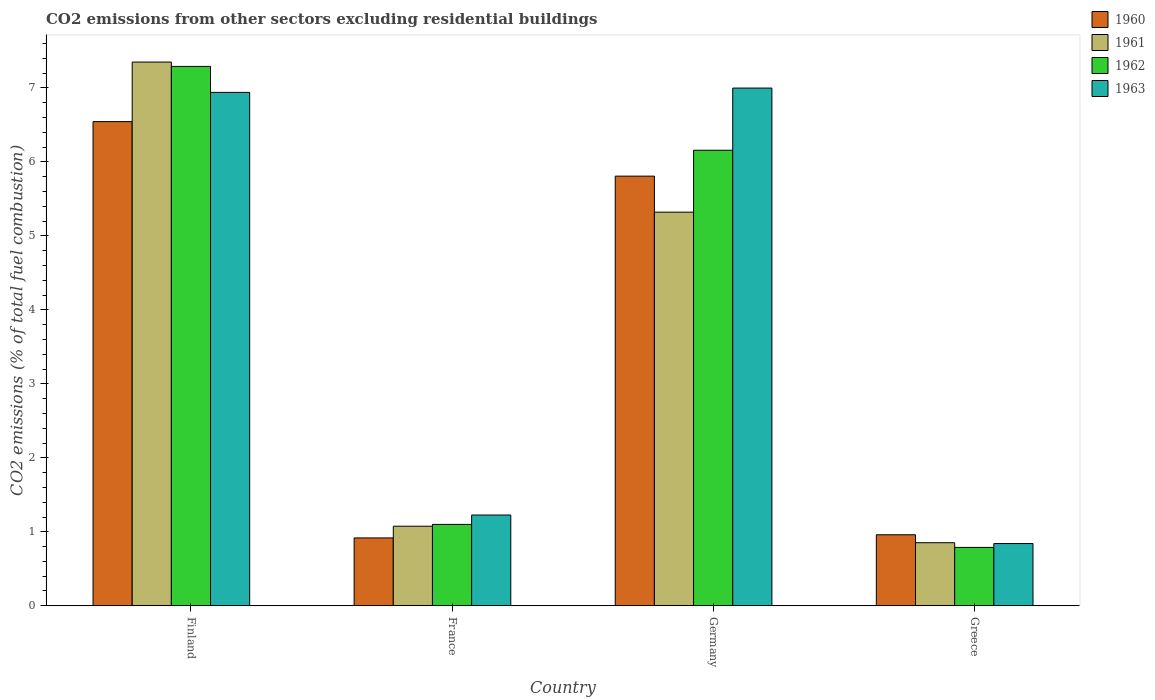How many different coloured bars are there?
Give a very brief answer. 4. Are the number of bars per tick equal to the number of legend labels?
Keep it short and to the point. Yes. How many bars are there on the 4th tick from the left?
Provide a succinct answer. 4. What is the label of the 1st group of bars from the left?
Offer a terse response. Finland. In how many cases, is the number of bars for a given country not equal to the number of legend labels?
Your answer should be very brief. 0. What is the total CO2 emitted in 1961 in Finland?
Provide a short and direct response. 7.35. Across all countries, what is the maximum total CO2 emitted in 1963?
Offer a very short reply. 7. Across all countries, what is the minimum total CO2 emitted in 1961?
Provide a short and direct response. 0.85. In which country was the total CO2 emitted in 1960 maximum?
Keep it short and to the point. Finland. What is the total total CO2 emitted in 1961 in the graph?
Ensure brevity in your answer.  14.6. What is the difference between the total CO2 emitted in 1960 in France and that in Greece?
Make the answer very short. -0.04. What is the difference between the total CO2 emitted in 1962 in Germany and the total CO2 emitted in 1961 in Finland?
Your response must be concise. -1.19. What is the average total CO2 emitted in 1961 per country?
Give a very brief answer. 3.65. What is the difference between the total CO2 emitted of/in 1960 and total CO2 emitted of/in 1962 in Greece?
Ensure brevity in your answer.  0.17. What is the ratio of the total CO2 emitted in 1963 in Germany to that in Greece?
Your answer should be compact. 8.32. What is the difference between the highest and the second highest total CO2 emitted in 1960?
Ensure brevity in your answer.  -4.85. What is the difference between the highest and the lowest total CO2 emitted in 1961?
Your response must be concise. 6.5. Is it the case that in every country, the sum of the total CO2 emitted in 1960 and total CO2 emitted in 1962 is greater than the sum of total CO2 emitted in 1963 and total CO2 emitted in 1961?
Your answer should be compact. No. What does the 1st bar from the left in Germany represents?
Provide a succinct answer. 1960. How many bars are there?
Offer a terse response. 16. Are the values on the major ticks of Y-axis written in scientific E-notation?
Ensure brevity in your answer.  No. Does the graph contain any zero values?
Ensure brevity in your answer.  No. Does the graph contain grids?
Ensure brevity in your answer.  No. How many legend labels are there?
Provide a short and direct response. 4. How are the legend labels stacked?
Your answer should be compact. Vertical. What is the title of the graph?
Offer a very short reply. CO2 emissions from other sectors excluding residential buildings. Does "2012" appear as one of the legend labels in the graph?
Provide a short and direct response. No. What is the label or title of the X-axis?
Your response must be concise. Country. What is the label or title of the Y-axis?
Give a very brief answer. CO2 emissions (% of total fuel combustion). What is the CO2 emissions (% of total fuel combustion) of 1960 in Finland?
Give a very brief answer. 6.54. What is the CO2 emissions (% of total fuel combustion) in 1961 in Finland?
Your answer should be very brief. 7.35. What is the CO2 emissions (% of total fuel combustion) of 1962 in Finland?
Provide a short and direct response. 7.29. What is the CO2 emissions (% of total fuel combustion) in 1963 in Finland?
Offer a terse response. 6.94. What is the CO2 emissions (% of total fuel combustion) of 1960 in France?
Offer a terse response. 0.92. What is the CO2 emissions (% of total fuel combustion) of 1961 in France?
Offer a very short reply. 1.08. What is the CO2 emissions (% of total fuel combustion) in 1962 in France?
Keep it short and to the point. 1.1. What is the CO2 emissions (% of total fuel combustion) in 1963 in France?
Your answer should be very brief. 1.23. What is the CO2 emissions (% of total fuel combustion) in 1960 in Germany?
Offer a very short reply. 5.81. What is the CO2 emissions (% of total fuel combustion) in 1961 in Germany?
Your response must be concise. 5.32. What is the CO2 emissions (% of total fuel combustion) in 1962 in Germany?
Keep it short and to the point. 6.16. What is the CO2 emissions (% of total fuel combustion) in 1963 in Germany?
Your response must be concise. 7. What is the CO2 emissions (% of total fuel combustion) of 1960 in Greece?
Offer a terse response. 0.96. What is the CO2 emissions (% of total fuel combustion) in 1961 in Greece?
Offer a terse response. 0.85. What is the CO2 emissions (% of total fuel combustion) of 1962 in Greece?
Your answer should be compact. 0.79. What is the CO2 emissions (% of total fuel combustion) of 1963 in Greece?
Your response must be concise. 0.84. Across all countries, what is the maximum CO2 emissions (% of total fuel combustion) of 1960?
Ensure brevity in your answer.  6.54. Across all countries, what is the maximum CO2 emissions (% of total fuel combustion) of 1961?
Ensure brevity in your answer.  7.35. Across all countries, what is the maximum CO2 emissions (% of total fuel combustion) in 1962?
Keep it short and to the point. 7.29. Across all countries, what is the maximum CO2 emissions (% of total fuel combustion) in 1963?
Provide a succinct answer. 7. Across all countries, what is the minimum CO2 emissions (% of total fuel combustion) of 1960?
Ensure brevity in your answer.  0.92. Across all countries, what is the minimum CO2 emissions (% of total fuel combustion) of 1961?
Provide a succinct answer. 0.85. Across all countries, what is the minimum CO2 emissions (% of total fuel combustion) of 1962?
Provide a short and direct response. 0.79. Across all countries, what is the minimum CO2 emissions (% of total fuel combustion) of 1963?
Offer a terse response. 0.84. What is the total CO2 emissions (% of total fuel combustion) in 1960 in the graph?
Your response must be concise. 14.23. What is the total CO2 emissions (% of total fuel combustion) of 1961 in the graph?
Provide a succinct answer. 14.6. What is the total CO2 emissions (% of total fuel combustion) of 1962 in the graph?
Give a very brief answer. 15.34. What is the total CO2 emissions (% of total fuel combustion) of 1963 in the graph?
Offer a terse response. 16.01. What is the difference between the CO2 emissions (% of total fuel combustion) of 1960 in Finland and that in France?
Your answer should be very brief. 5.63. What is the difference between the CO2 emissions (% of total fuel combustion) in 1961 in Finland and that in France?
Make the answer very short. 6.27. What is the difference between the CO2 emissions (% of total fuel combustion) of 1962 in Finland and that in France?
Offer a very short reply. 6.19. What is the difference between the CO2 emissions (% of total fuel combustion) in 1963 in Finland and that in France?
Make the answer very short. 5.71. What is the difference between the CO2 emissions (% of total fuel combustion) in 1960 in Finland and that in Germany?
Your response must be concise. 0.74. What is the difference between the CO2 emissions (% of total fuel combustion) of 1961 in Finland and that in Germany?
Your answer should be very brief. 2.03. What is the difference between the CO2 emissions (% of total fuel combustion) of 1962 in Finland and that in Germany?
Provide a short and direct response. 1.13. What is the difference between the CO2 emissions (% of total fuel combustion) in 1963 in Finland and that in Germany?
Offer a very short reply. -0.06. What is the difference between the CO2 emissions (% of total fuel combustion) in 1960 in Finland and that in Greece?
Ensure brevity in your answer.  5.58. What is the difference between the CO2 emissions (% of total fuel combustion) of 1961 in Finland and that in Greece?
Provide a short and direct response. 6.5. What is the difference between the CO2 emissions (% of total fuel combustion) of 1962 in Finland and that in Greece?
Your answer should be very brief. 6.5. What is the difference between the CO2 emissions (% of total fuel combustion) of 1963 in Finland and that in Greece?
Give a very brief answer. 6.1. What is the difference between the CO2 emissions (% of total fuel combustion) in 1960 in France and that in Germany?
Provide a succinct answer. -4.89. What is the difference between the CO2 emissions (% of total fuel combustion) in 1961 in France and that in Germany?
Offer a terse response. -4.25. What is the difference between the CO2 emissions (% of total fuel combustion) in 1962 in France and that in Germany?
Offer a terse response. -5.06. What is the difference between the CO2 emissions (% of total fuel combustion) in 1963 in France and that in Germany?
Give a very brief answer. -5.77. What is the difference between the CO2 emissions (% of total fuel combustion) in 1960 in France and that in Greece?
Give a very brief answer. -0.04. What is the difference between the CO2 emissions (% of total fuel combustion) of 1961 in France and that in Greece?
Make the answer very short. 0.22. What is the difference between the CO2 emissions (% of total fuel combustion) in 1962 in France and that in Greece?
Offer a terse response. 0.31. What is the difference between the CO2 emissions (% of total fuel combustion) of 1963 in France and that in Greece?
Ensure brevity in your answer.  0.39. What is the difference between the CO2 emissions (% of total fuel combustion) in 1960 in Germany and that in Greece?
Give a very brief answer. 4.85. What is the difference between the CO2 emissions (% of total fuel combustion) of 1961 in Germany and that in Greece?
Your answer should be very brief. 4.47. What is the difference between the CO2 emissions (% of total fuel combustion) of 1962 in Germany and that in Greece?
Ensure brevity in your answer.  5.37. What is the difference between the CO2 emissions (% of total fuel combustion) of 1963 in Germany and that in Greece?
Your answer should be compact. 6.16. What is the difference between the CO2 emissions (% of total fuel combustion) in 1960 in Finland and the CO2 emissions (% of total fuel combustion) in 1961 in France?
Ensure brevity in your answer.  5.47. What is the difference between the CO2 emissions (% of total fuel combustion) of 1960 in Finland and the CO2 emissions (% of total fuel combustion) of 1962 in France?
Your answer should be very brief. 5.44. What is the difference between the CO2 emissions (% of total fuel combustion) in 1960 in Finland and the CO2 emissions (% of total fuel combustion) in 1963 in France?
Your response must be concise. 5.32. What is the difference between the CO2 emissions (% of total fuel combustion) in 1961 in Finland and the CO2 emissions (% of total fuel combustion) in 1962 in France?
Keep it short and to the point. 6.25. What is the difference between the CO2 emissions (% of total fuel combustion) of 1961 in Finland and the CO2 emissions (% of total fuel combustion) of 1963 in France?
Your answer should be very brief. 6.12. What is the difference between the CO2 emissions (% of total fuel combustion) of 1962 in Finland and the CO2 emissions (% of total fuel combustion) of 1963 in France?
Your response must be concise. 6.06. What is the difference between the CO2 emissions (% of total fuel combustion) of 1960 in Finland and the CO2 emissions (% of total fuel combustion) of 1961 in Germany?
Your answer should be compact. 1.22. What is the difference between the CO2 emissions (% of total fuel combustion) in 1960 in Finland and the CO2 emissions (% of total fuel combustion) in 1962 in Germany?
Provide a short and direct response. 0.39. What is the difference between the CO2 emissions (% of total fuel combustion) in 1960 in Finland and the CO2 emissions (% of total fuel combustion) in 1963 in Germany?
Give a very brief answer. -0.45. What is the difference between the CO2 emissions (% of total fuel combustion) of 1961 in Finland and the CO2 emissions (% of total fuel combustion) of 1962 in Germany?
Your answer should be very brief. 1.19. What is the difference between the CO2 emissions (% of total fuel combustion) of 1961 in Finland and the CO2 emissions (% of total fuel combustion) of 1963 in Germany?
Your answer should be compact. 0.35. What is the difference between the CO2 emissions (% of total fuel combustion) in 1962 in Finland and the CO2 emissions (% of total fuel combustion) in 1963 in Germany?
Offer a very short reply. 0.29. What is the difference between the CO2 emissions (% of total fuel combustion) of 1960 in Finland and the CO2 emissions (% of total fuel combustion) of 1961 in Greece?
Your response must be concise. 5.69. What is the difference between the CO2 emissions (% of total fuel combustion) of 1960 in Finland and the CO2 emissions (% of total fuel combustion) of 1962 in Greece?
Offer a very short reply. 5.76. What is the difference between the CO2 emissions (% of total fuel combustion) of 1960 in Finland and the CO2 emissions (% of total fuel combustion) of 1963 in Greece?
Ensure brevity in your answer.  5.7. What is the difference between the CO2 emissions (% of total fuel combustion) of 1961 in Finland and the CO2 emissions (% of total fuel combustion) of 1962 in Greece?
Give a very brief answer. 6.56. What is the difference between the CO2 emissions (% of total fuel combustion) in 1961 in Finland and the CO2 emissions (% of total fuel combustion) in 1963 in Greece?
Give a very brief answer. 6.51. What is the difference between the CO2 emissions (% of total fuel combustion) of 1962 in Finland and the CO2 emissions (% of total fuel combustion) of 1963 in Greece?
Offer a very short reply. 6.45. What is the difference between the CO2 emissions (% of total fuel combustion) in 1960 in France and the CO2 emissions (% of total fuel combustion) in 1961 in Germany?
Ensure brevity in your answer.  -4.4. What is the difference between the CO2 emissions (% of total fuel combustion) of 1960 in France and the CO2 emissions (% of total fuel combustion) of 1962 in Germany?
Your response must be concise. -5.24. What is the difference between the CO2 emissions (% of total fuel combustion) of 1960 in France and the CO2 emissions (% of total fuel combustion) of 1963 in Germany?
Your answer should be compact. -6.08. What is the difference between the CO2 emissions (% of total fuel combustion) in 1961 in France and the CO2 emissions (% of total fuel combustion) in 1962 in Germany?
Offer a very short reply. -5.08. What is the difference between the CO2 emissions (% of total fuel combustion) of 1961 in France and the CO2 emissions (% of total fuel combustion) of 1963 in Germany?
Provide a succinct answer. -5.92. What is the difference between the CO2 emissions (% of total fuel combustion) in 1962 in France and the CO2 emissions (% of total fuel combustion) in 1963 in Germany?
Your answer should be very brief. -5.9. What is the difference between the CO2 emissions (% of total fuel combustion) in 1960 in France and the CO2 emissions (% of total fuel combustion) in 1961 in Greece?
Ensure brevity in your answer.  0.06. What is the difference between the CO2 emissions (% of total fuel combustion) of 1960 in France and the CO2 emissions (% of total fuel combustion) of 1962 in Greece?
Your response must be concise. 0.13. What is the difference between the CO2 emissions (% of total fuel combustion) in 1960 in France and the CO2 emissions (% of total fuel combustion) in 1963 in Greece?
Provide a succinct answer. 0.08. What is the difference between the CO2 emissions (% of total fuel combustion) of 1961 in France and the CO2 emissions (% of total fuel combustion) of 1962 in Greece?
Provide a succinct answer. 0.29. What is the difference between the CO2 emissions (% of total fuel combustion) in 1961 in France and the CO2 emissions (% of total fuel combustion) in 1963 in Greece?
Give a very brief answer. 0.23. What is the difference between the CO2 emissions (% of total fuel combustion) of 1962 in France and the CO2 emissions (% of total fuel combustion) of 1963 in Greece?
Ensure brevity in your answer.  0.26. What is the difference between the CO2 emissions (% of total fuel combustion) of 1960 in Germany and the CO2 emissions (% of total fuel combustion) of 1961 in Greece?
Make the answer very short. 4.96. What is the difference between the CO2 emissions (% of total fuel combustion) of 1960 in Germany and the CO2 emissions (% of total fuel combustion) of 1962 in Greece?
Make the answer very short. 5.02. What is the difference between the CO2 emissions (% of total fuel combustion) of 1960 in Germany and the CO2 emissions (% of total fuel combustion) of 1963 in Greece?
Ensure brevity in your answer.  4.97. What is the difference between the CO2 emissions (% of total fuel combustion) in 1961 in Germany and the CO2 emissions (% of total fuel combustion) in 1962 in Greece?
Keep it short and to the point. 4.53. What is the difference between the CO2 emissions (% of total fuel combustion) in 1961 in Germany and the CO2 emissions (% of total fuel combustion) in 1963 in Greece?
Your response must be concise. 4.48. What is the difference between the CO2 emissions (% of total fuel combustion) of 1962 in Germany and the CO2 emissions (% of total fuel combustion) of 1963 in Greece?
Offer a terse response. 5.32. What is the average CO2 emissions (% of total fuel combustion) of 1960 per country?
Offer a terse response. 3.56. What is the average CO2 emissions (% of total fuel combustion) of 1961 per country?
Ensure brevity in your answer.  3.65. What is the average CO2 emissions (% of total fuel combustion) in 1962 per country?
Offer a terse response. 3.83. What is the average CO2 emissions (% of total fuel combustion) of 1963 per country?
Keep it short and to the point. 4. What is the difference between the CO2 emissions (% of total fuel combustion) in 1960 and CO2 emissions (% of total fuel combustion) in 1961 in Finland?
Your response must be concise. -0.81. What is the difference between the CO2 emissions (% of total fuel combustion) of 1960 and CO2 emissions (% of total fuel combustion) of 1962 in Finland?
Provide a succinct answer. -0.75. What is the difference between the CO2 emissions (% of total fuel combustion) of 1960 and CO2 emissions (% of total fuel combustion) of 1963 in Finland?
Your answer should be compact. -0.4. What is the difference between the CO2 emissions (% of total fuel combustion) in 1961 and CO2 emissions (% of total fuel combustion) in 1962 in Finland?
Your answer should be compact. 0.06. What is the difference between the CO2 emissions (% of total fuel combustion) in 1961 and CO2 emissions (% of total fuel combustion) in 1963 in Finland?
Your response must be concise. 0.41. What is the difference between the CO2 emissions (% of total fuel combustion) of 1962 and CO2 emissions (% of total fuel combustion) of 1963 in Finland?
Your answer should be compact. 0.35. What is the difference between the CO2 emissions (% of total fuel combustion) in 1960 and CO2 emissions (% of total fuel combustion) in 1961 in France?
Your answer should be compact. -0.16. What is the difference between the CO2 emissions (% of total fuel combustion) in 1960 and CO2 emissions (% of total fuel combustion) in 1962 in France?
Ensure brevity in your answer.  -0.18. What is the difference between the CO2 emissions (% of total fuel combustion) in 1960 and CO2 emissions (% of total fuel combustion) in 1963 in France?
Provide a short and direct response. -0.31. What is the difference between the CO2 emissions (% of total fuel combustion) in 1961 and CO2 emissions (% of total fuel combustion) in 1962 in France?
Your answer should be compact. -0.02. What is the difference between the CO2 emissions (% of total fuel combustion) in 1961 and CO2 emissions (% of total fuel combustion) in 1963 in France?
Your response must be concise. -0.15. What is the difference between the CO2 emissions (% of total fuel combustion) of 1962 and CO2 emissions (% of total fuel combustion) of 1963 in France?
Keep it short and to the point. -0.13. What is the difference between the CO2 emissions (% of total fuel combustion) in 1960 and CO2 emissions (% of total fuel combustion) in 1961 in Germany?
Give a very brief answer. 0.49. What is the difference between the CO2 emissions (% of total fuel combustion) in 1960 and CO2 emissions (% of total fuel combustion) in 1962 in Germany?
Provide a short and direct response. -0.35. What is the difference between the CO2 emissions (% of total fuel combustion) of 1960 and CO2 emissions (% of total fuel combustion) of 1963 in Germany?
Keep it short and to the point. -1.19. What is the difference between the CO2 emissions (% of total fuel combustion) in 1961 and CO2 emissions (% of total fuel combustion) in 1962 in Germany?
Provide a succinct answer. -0.84. What is the difference between the CO2 emissions (% of total fuel combustion) of 1961 and CO2 emissions (% of total fuel combustion) of 1963 in Germany?
Your answer should be very brief. -1.68. What is the difference between the CO2 emissions (% of total fuel combustion) of 1962 and CO2 emissions (% of total fuel combustion) of 1963 in Germany?
Keep it short and to the point. -0.84. What is the difference between the CO2 emissions (% of total fuel combustion) in 1960 and CO2 emissions (% of total fuel combustion) in 1961 in Greece?
Offer a very short reply. 0.11. What is the difference between the CO2 emissions (% of total fuel combustion) of 1960 and CO2 emissions (% of total fuel combustion) of 1962 in Greece?
Your answer should be very brief. 0.17. What is the difference between the CO2 emissions (% of total fuel combustion) of 1960 and CO2 emissions (% of total fuel combustion) of 1963 in Greece?
Your response must be concise. 0.12. What is the difference between the CO2 emissions (% of total fuel combustion) of 1961 and CO2 emissions (% of total fuel combustion) of 1962 in Greece?
Provide a succinct answer. 0.06. What is the difference between the CO2 emissions (% of total fuel combustion) of 1961 and CO2 emissions (% of total fuel combustion) of 1963 in Greece?
Your answer should be compact. 0.01. What is the difference between the CO2 emissions (% of total fuel combustion) in 1962 and CO2 emissions (% of total fuel combustion) in 1963 in Greece?
Your response must be concise. -0.05. What is the ratio of the CO2 emissions (% of total fuel combustion) in 1960 in Finland to that in France?
Give a very brief answer. 7.14. What is the ratio of the CO2 emissions (% of total fuel combustion) of 1961 in Finland to that in France?
Keep it short and to the point. 6.83. What is the ratio of the CO2 emissions (% of total fuel combustion) in 1962 in Finland to that in France?
Provide a succinct answer. 6.63. What is the ratio of the CO2 emissions (% of total fuel combustion) in 1963 in Finland to that in France?
Provide a short and direct response. 5.66. What is the ratio of the CO2 emissions (% of total fuel combustion) of 1960 in Finland to that in Germany?
Provide a succinct answer. 1.13. What is the ratio of the CO2 emissions (% of total fuel combustion) of 1961 in Finland to that in Germany?
Keep it short and to the point. 1.38. What is the ratio of the CO2 emissions (% of total fuel combustion) of 1962 in Finland to that in Germany?
Give a very brief answer. 1.18. What is the ratio of the CO2 emissions (% of total fuel combustion) in 1960 in Finland to that in Greece?
Your answer should be very brief. 6.82. What is the ratio of the CO2 emissions (% of total fuel combustion) in 1961 in Finland to that in Greece?
Provide a short and direct response. 8.62. What is the ratio of the CO2 emissions (% of total fuel combustion) of 1962 in Finland to that in Greece?
Provide a succinct answer. 9.24. What is the ratio of the CO2 emissions (% of total fuel combustion) in 1963 in Finland to that in Greece?
Give a very brief answer. 8.25. What is the ratio of the CO2 emissions (% of total fuel combustion) of 1960 in France to that in Germany?
Your answer should be very brief. 0.16. What is the ratio of the CO2 emissions (% of total fuel combustion) in 1961 in France to that in Germany?
Provide a short and direct response. 0.2. What is the ratio of the CO2 emissions (% of total fuel combustion) of 1962 in France to that in Germany?
Your answer should be very brief. 0.18. What is the ratio of the CO2 emissions (% of total fuel combustion) in 1963 in France to that in Germany?
Ensure brevity in your answer.  0.18. What is the ratio of the CO2 emissions (% of total fuel combustion) of 1960 in France to that in Greece?
Offer a very short reply. 0.96. What is the ratio of the CO2 emissions (% of total fuel combustion) of 1961 in France to that in Greece?
Offer a terse response. 1.26. What is the ratio of the CO2 emissions (% of total fuel combustion) of 1962 in France to that in Greece?
Your response must be concise. 1.39. What is the ratio of the CO2 emissions (% of total fuel combustion) in 1963 in France to that in Greece?
Your answer should be compact. 1.46. What is the ratio of the CO2 emissions (% of total fuel combustion) of 1960 in Germany to that in Greece?
Your answer should be very brief. 6.05. What is the ratio of the CO2 emissions (% of total fuel combustion) in 1961 in Germany to that in Greece?
Keep it short and to the point. 6.24. What is the ratio of the CO2 emissions (% of total fuel combustion) in 1962 in Germany to that in Greece?
Offer a very short reply. 7.8. What is the ratio of the CO2 emissions (% of total fuel combustion) in 1963 in Germany to that in Greece?
Keep it short and to the point. 8.32. What is the difference between the highest and the second highest CO2 emissions (% of total fuel combustion) of 1960?
Give a very brief answer. 0.74. What is the difference between the highest and the second highest CO2 emissions (% of total fuel combustion) in 1961?
Ensure brevity in your answer.  2.03. What is the difference between the highest and the second highest CO2 emissions (% of total fuel combustion) in 1962?
Give a very brief answer. 1.13. What is the difference between the highest and the second highest CO2 emissions (% of total fuel combustion) of 1963?
Ensure brevity in your answer.  0.06. What is the difference between the highest and the lowest CO2 emissions (% of total fuel combustion) in 1960?
Your answer should be compact. 5.63. What is the difference between the highest and the lowest CO2 emissions (% of total fuel combustion) in 1961?
Give a very brief answer. 6.5. What is the difference between the highest and the lowest CO2 emissions (% of total fuel combustion) in 1962?
Keep it short and to the point. 6.5. What is the difference between the highest and the lowest CO2 emissions (% of total fuel combustion) of 1963?
Your response must be concise. 6.16. 